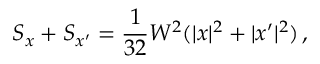<formula> <loc_0><loc_0><loc_500><loc_500>S _ { x } + S _ { x ^ { \prime } } = \frac { 1 } { 3 2 } W ^ { 2 } ( | x | ^ { 2 } + | x ^ { \prime } | ^ { 2 } ) \, ,</formula> 